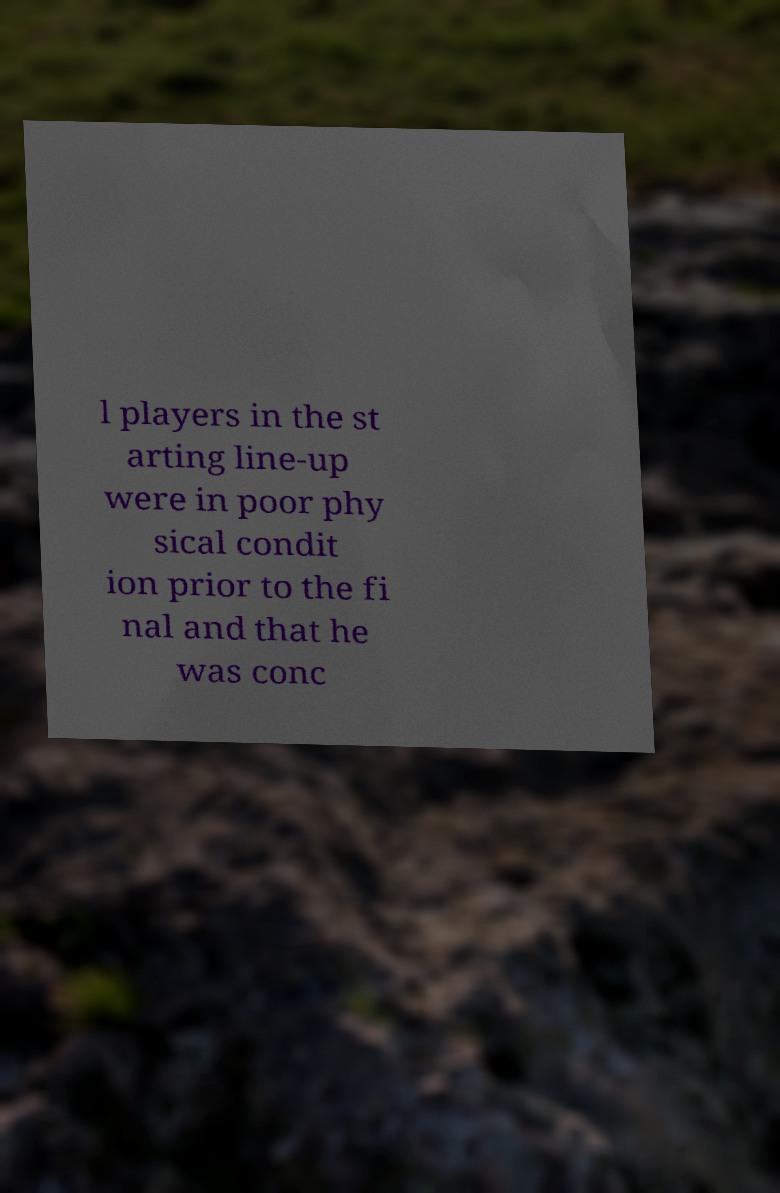What messages or text are displayed in this image? I need them in a readable, typed format. l players in the st arting line-up were in poor phy sical condit ion prior to the fi nal and that he was conc 